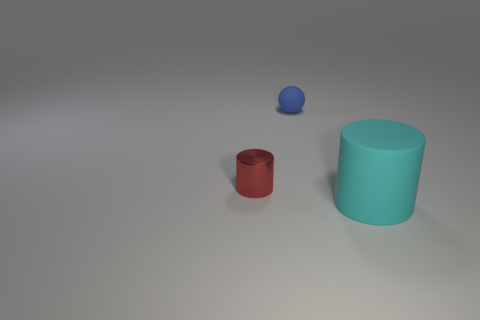Add 2 tiny cyan rubber things. How many objects exist? 5 Subtract all cylinders. How many objects are left? 1 Subtract all blue cylinders. Subtract all purple balls. How many cylinders are left? 2 Subtract all big cyan matte cylinders. Subtract all large cyan cylinders. How many objects are left? 1 Add 2 red cylinders. How many red cylinders are left? 3 Add 1 large green metallic spheres. How many large green metallic spheres exist? 1 Subtract 0 cyan balls. How many objects are left? 3 